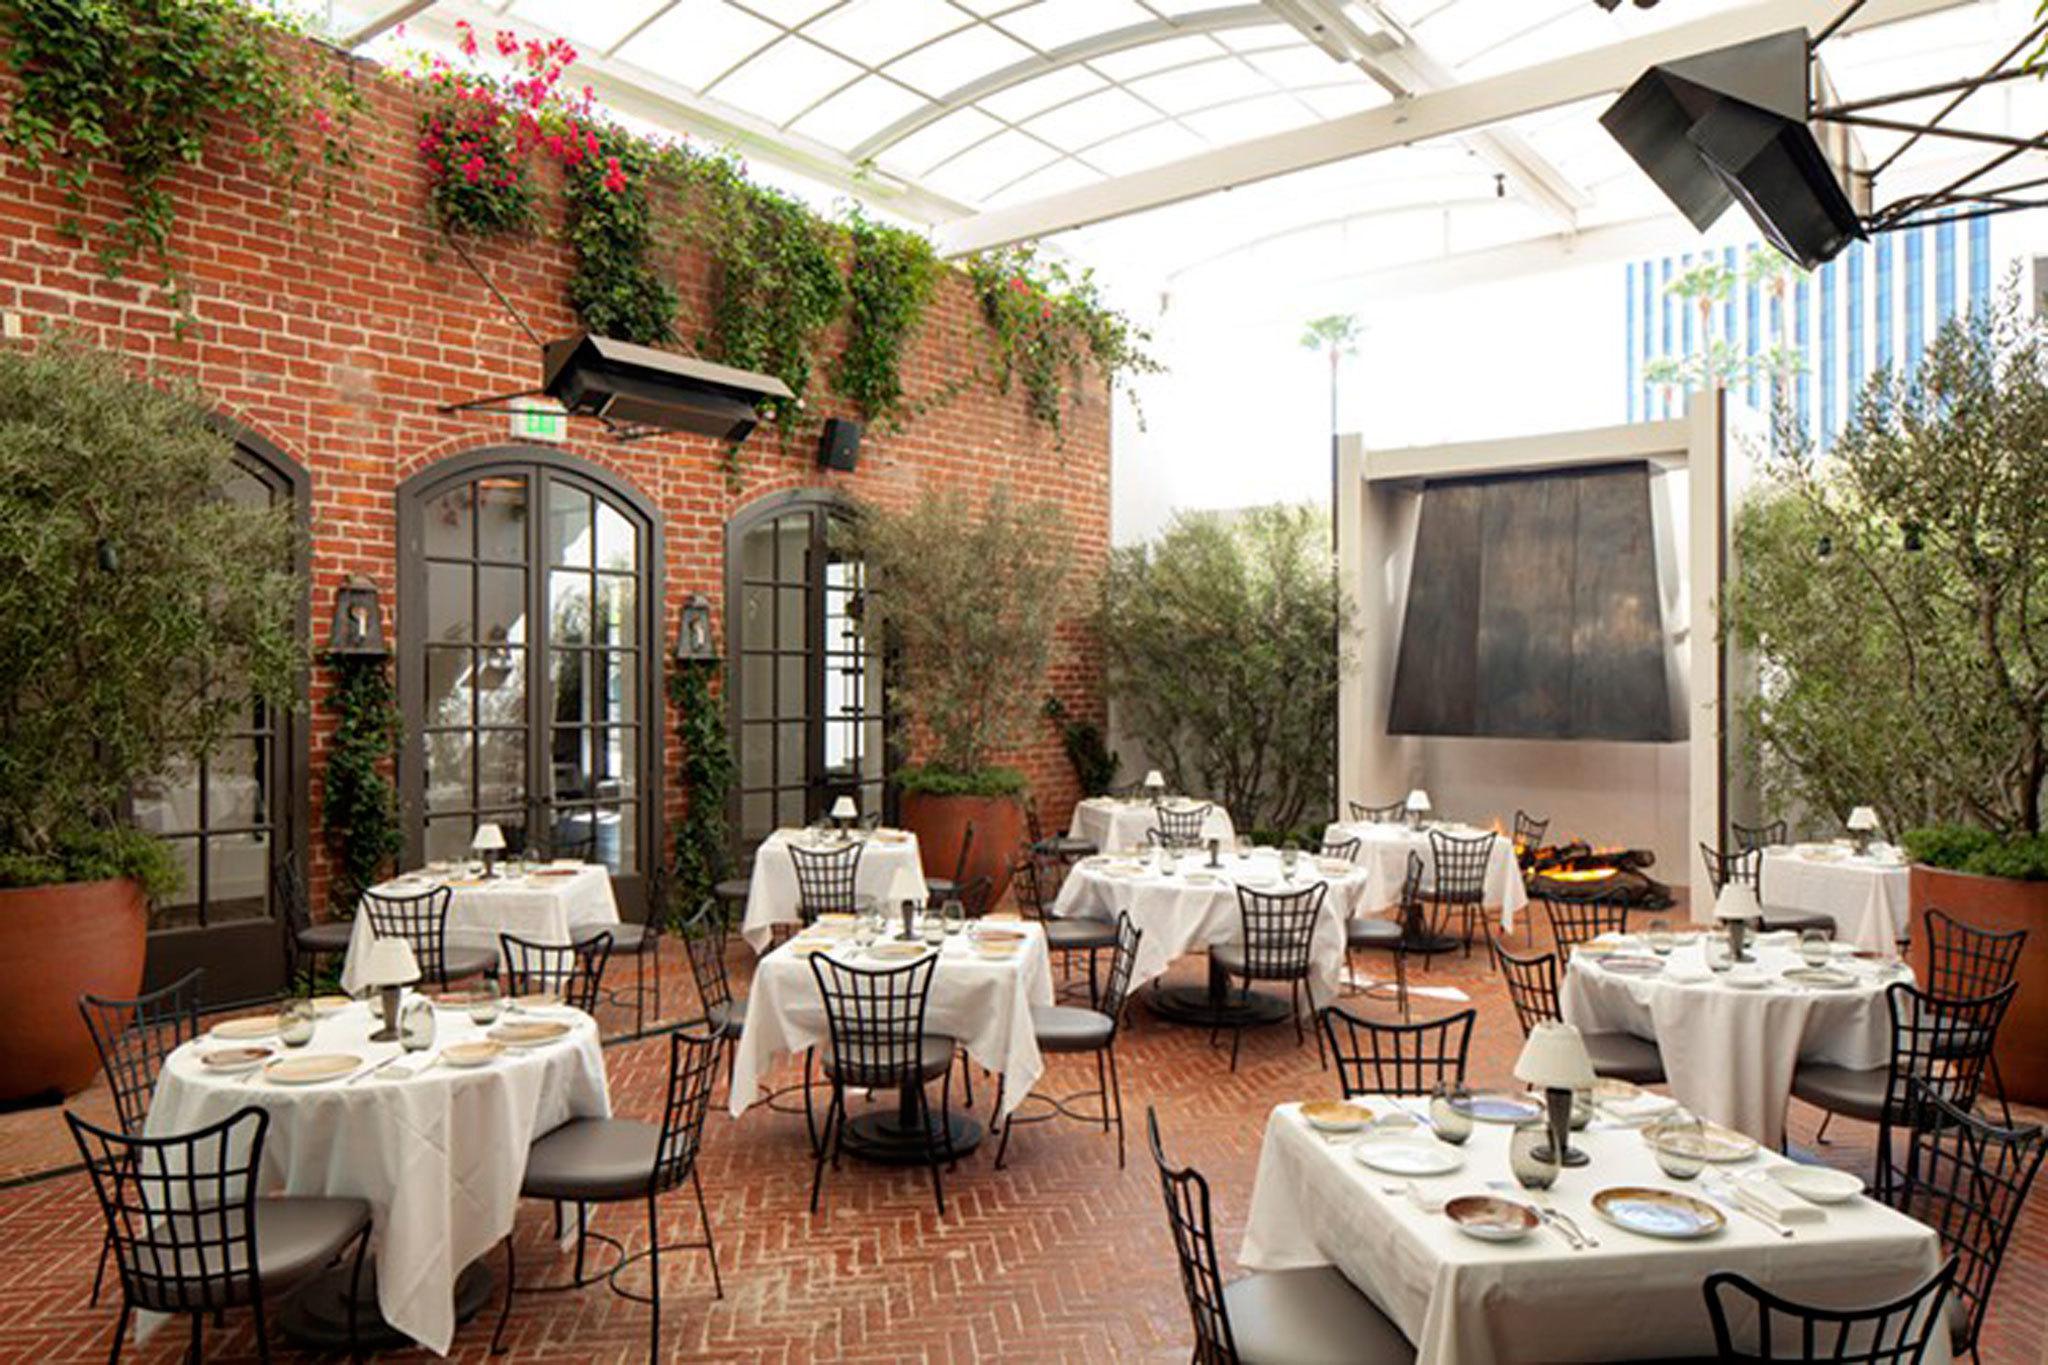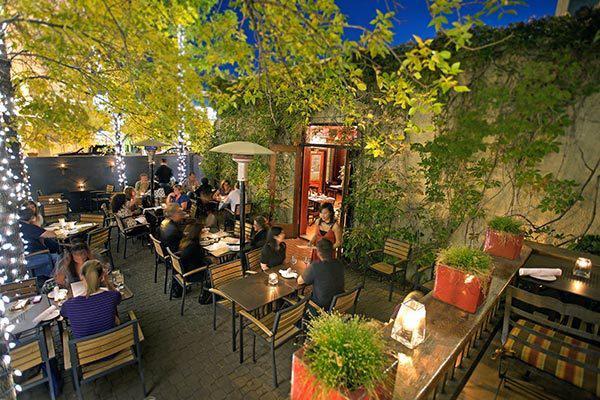The first image is the image on the left, the second image is the image on the right. Examine the images to the left and right. Is the description "Umbrellas are set up over a dining area in the image on the right." accurate? Answer yes or no. No. The first image is the image on the left, the second image is the image on the right. For the images shown, is this caption "There area at least six tables covered in white linen with four chairs around them." true? Answer yes or no. Yes. 